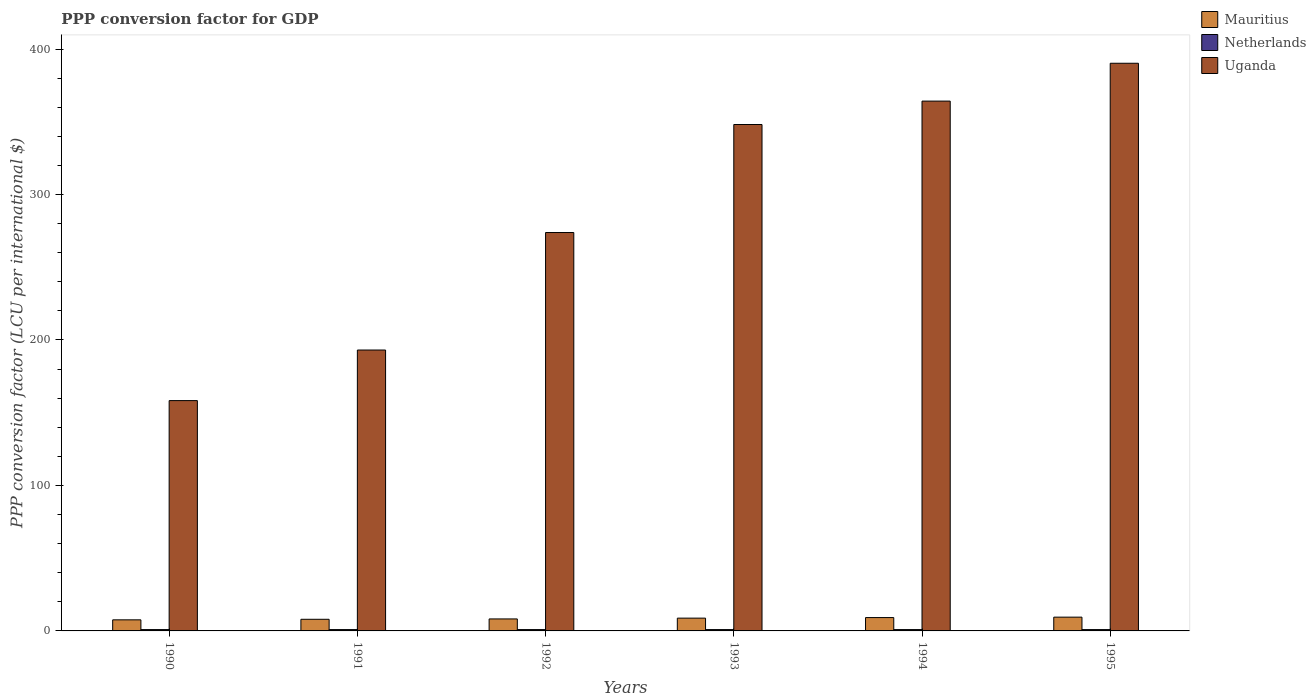How many different coloured bars are there?
Offer a very short reply. 3. Are the number of bars per tick equal to the number of legend labels?
Offer a terse response. Yes. Are the number of bars on each tick of the X-axis equal?
Keep it short and to the point. Yes. How many bars are there on the 2nd tick from the right?
Keep it short and to the point. 3. In how many cases, is the number of bars for a given year not equal to the number of legend labels?
Make the answer very short. 0. What is the PPP conversion factor for GDP in Netherlands in 1993?
Make the answer very short. 0.92. Across all years, what is the maximum PPP conversion factor for GDP in Mauritius?
Keep it short and to the point. 9.47. Across all years, what is the minimum PPP conversion factor for GDP in Netherlands?
Provide a succinct answer. 0.92. In which year was the PPP conversion factor for GDP in Mauritius minimum?
Your answer should be compact. 1990. What is the total PPP conversion factor for GDP in Uganda in the graph?
Your answer should be very brief. 1727.85. What is the difference between the PPP conversion factor for GDP in Mauritius in 1991 and that in 1993?
Your response must be concise. -0.79. What is the difference between the PPP conversion factor for GDP in Netherlands in 1992 and the PPP conversion factor for GDP in Uganda in 1991?
Ensure brevity in your answer.  -192.17. What is the average PPP conversion factor for GDP in Uganda per year?
Make the answer very short. 287.98. In the year 1993, what is the difference between the PPP conversion factor for GDP in Netherlands and PPP conversion factor for GDP in Uganda?
Keep it short and to the point. -347.21. What is the ratio of the PPP conversion factor for GDP in Netherlands in 1991 to that in 1993?
Give a very brief answer. 1.01. Is the difference between the PPP conversion factor for GDP in Netherlands in 1990 and 1991 greater than the difference between the PPP conversion factor for GDP in Uganda in 1990 and 1991?
Offer a terse response. Yes. What is the difference between the highest and the second highest PPP conversion factor for GDP in Netherlands?
Make the answer very short. 5.700000000008476e-5. What is the difference between the highest and the lowest PPP conversion factor for GDP in Mauritius?
Offer a terse response. 1.86. In how many years, is the PPP conversion factor for GDP in Netherlands greater than the average PPP conversion factor for GDP in Netherlands taken over all years?
Your answer should be compact. 3. What does the 1st bar from the left in 1995 represents?
Your response must be concise. Mauritius. What does the 2nd bar from the right in 1992 represents?
Your answer should be very brief. Netherlands. Is it the case that in every year, the sum of the PPP conversion factor for GDP in Netherlands and PPP conversion factor for GDP in Uganda is greater than the PPP conversion factor for GDP in Mauritius?
Offer a terse response. Yes. Are all the bars in the graph horizontal?
Provide a succinct answer. No. What is the difference between two consecutive major ticks on the Y-axis?
Provide a short and direct response. 100. Are the values on the major ticks of Y-axis written in scientific E-notation?
Offer a terse response. No. Where does the legend appear in the graph?
Make the answer very short. Top right. What is the title of the graph?
Offer a very short reply. PPP conversion factor for GDP. What is the label or title of the Y-axis?
Make the answer very short. PPP conversion factor (LCU per international $). What is the PPP conversion factor (LCU per international $) of Mauritius in 1990?
Ensure brevity in your answer.  7.62. What is the PPP conversion factor (LCU per international $) in Netherlands in 1990?
Give a very brief answer. 0.92. What is the PPP conversion factor (LCU per international $) of Uganda in 1990?
Provide a short and direct response. 158.32. What is the PPP conversion factor (LCU per international $) of Mauritius in 1991?
Keep it short and to the point. 8. What is the PPP conversion factor (LCU per international $) in Netherlands in 1991?
Offer a terse response. 0.92. What is the PPP conversion factor (LCU per international $) of Uganda in 1991?
Your response must be concise. 193.09. What is the PPP conversion factor (LCU per international $) of Mauritius in 1992?
Offer a terse response. 8.24. What is the PPP conversion factor (LCU per international $) in Netherlands in 1992?
Your answer should be very brief. 0.92. What is the PPP conversion factor (LCU per international $) of Uganda in 1992?
Offer a very short reply. 273.87. What is the PPP conversion factor (LCU per international $) in Mauritius in 1993?
Offer a terse response. 8.79. What is the PPP conversion factor (LCU per international $) in Netherlands in 1993?
Provide a succinct answer. 0.92. What is the PPP conversion factor (LCU per international $) in Uganda in 1993?
Provide a short and direct response. 348.12. What is the PPP conversion factor (LCU per international $) of Mauritius in 1994?
Make the answer very short. 9.17. What is the PPP conversion factor (LCU per international $) of Netherlands in 1994?
Ensure brevity in your answer.  0.92. What is the PPP conversion factor (LCU per international $) in Uganda in 1994?
Provide a succinct answer. 364.21. What is the PPP conversion factor (LCU per international $) of Mauritius in 1995?
Provide a short and direct response. 9.47. What is the PPP conversion factor (LCU per international $) of Netherlands in 1995?
Provide a succinct answer. 0.92. What is the PPP conversion factor (LCU per international $) in Uganda in 1995?
Offer a very short reply. 390.23. Across all years, what is the maximum PPP conversion factor (LCU per international $) of Mauritius?
Provide a succinct answer. 9.47. Across all years, what is the maximum PPP conversion factor (LCU per international $) in Netherlands?
Provide a short and direct response. 0.92. Across all years, what is the maximum PPP conversion factor (LCU per international $) of Uganda?
Keep it short and to the point. 390.23. Across all years, what is the minimum PPP conversion factor (LCU per international $) in Mauritius?
Your response must be concise. 7.62. Across all years, what is the minimum PPP conversion factor (LCU per international $) of Netherlands?
Keep it short and to the point. 0.92. Across all years, what is the minimum PPP conversion factor (LCU per international $) in Uganda?
Provide a short and direct response. 158.32. What is the total PPP conversion factor (LCU per international $) in Mauritius in the graph?
Provide a short and direct response. 51.3. What is the total PPP conversion factor (LCU per international $) in Netherlands in the graph?
Your answer should be compact. 5.51. What is the total PPP conversion factor (LCU per international $) of Uganda in the graph?
Give a very brief answer. 1727.85. What is the difference between the PPP conversion factor (LCU per international $) in Mauritius in 1990 and that in 1991?
Make the answer very short. -0.39. What is the difference between the PPP conversion factor (LCU per international $) in Netherlands in 1990 and that in 1991?
Your answer should be very brief. 0. What is the difference between the PPP conversion factor (LCU per international $) in Uganda in 1990 and that in 1991?
Make the answer very short. -34.77. What is the difference between the PPP conversion factor (LCU per international $) in Mauritius in 1990 and that in 1992?
Keep it short and to the point. -0.63. What is the difference between the PPP conversion factor (LCU per international $) in Netherlands in 1990 and that in 1992?
Ensure brevity in your answer.  -0. What is the difference between the PPP conversion factor (LCU per international $) of Uganda in 1990 and that in 1992?
Give a very brief answer. -115.55. What is the difference between the PPP conversion factor (LCU per international $) in Mauritius in 1990 and that in 1993?
Ensure brevity in your answer.  -1.18. What is the difference between the PPP conversion factor (LCU per international $) in Netherlands in 1990 and that in 1993?
Make the answer very short. 0.01. What is the difference between the PPP conversion factor (LCU per international $) of Uganda in 1990 and that in 1993?
Ensure brevity in your answer.  -189.8. What is the difference between the PPP conversion factor (LCU per international $) in Mauritius in 1990 and that in 1994?
Keep it short and to the point. -1.56. What is the difference between the PPP conversion factor (LCU per international $) in Netherlands in 1990 and that in 1994?
Your answer should be very brief. 0.01. What is the difference between the PPP conversion factor (LCU per international $) of Uganda in 1990 and that in 1994?
Provide a short and direct response. -205.89. What is the difference between the PPP conversion factor (LCU per international $) of Mauritius in 1990 and that in 1995?
Offer a terse response. -1.86. What is the difference between the PPP conversion factor (LCU per international $) in Netherlands in 1990 and that in 1995?
Your answer should be compact. 0.01. What is the difference between the PPP conversion factor (LCU per international $) of Uganda in 1990 and that in 1995?
Make the answer very short. -231.9. What is the difference between the PPP conversion factor (LCU per international $) in Mauritius in 1991 and that in 1992?
Your response must be concise. -0.24. What is the difference between the PPP conversion factor (LCU per international $) of Netherlands in 1991 and that in 1992?
Offer a terse response. -0. What is the difference between the PPP conversion factor (LCU per international $) in Uganda in 1991 and that in 1992?
Provide a short and direct response. -80.78. What is the difference between the PPP conversion factor (LCU per international $) in Mauritius in 1991 and that in 1993?
Your response must be concise. -0.79. What is the difference between the PPP conversion factor (LCU per international $) of Netherlands in 1991 and that in 1993?
Give a very brief answer. 0.01. What is the difference between the PPP conversion factor (LCU per international $) in Uganda in 1991 and that in 1993?
Offer a terse response. -155.03. What is the difference between the PPP conversion factor (LCU per international $) of Mauritius in 1991 and that in 1994?
Ensure brevity in your answer.  -1.17. What is the difference between the PPP conversion factor (LCU per international $) of Netherlands in 1991 and that in 1994?
Your answer should be very brief. 0.01. What is the difference between the PPP conversion factor (LCU per international $) in Uganda in 1991 and that in 1994?
Your answer should be compact. -171.12. What is the difference between the PPP conversion factor (LCU per international $) in Mauritius in 1991 and that in 1995?
Your answer should be very brief. -1.47. What is the difference between the PPP conversion factor (LCU per international $) of Netherlands in 1991 and that in 1995?
Provide a short and direct response. 0.01. What is the difference between the PPP conversion factor (LCU per international $) of Uganda in 1991 and that in 1995?
Give a very brief answer. -197.13. What is the difference between the PPP conversion factor (LCU per international $) in Mauritius in 1992 and that in 1993?
Offer a terse response. -0.55. What is the difference between the PPP conversion factor (LCU per international $) in Netherlands in 1992 and that in 1993?
Make the answer very short. 0.01. What is the difference between the PPP conversion factor (LCU per international $) of Uganda in 1992 and that in 1993?
Your response must be concise. -74.25. What is the difference between the PPP conversion factor (LCU per international $) in Mauritius in 1992 and that in 1994?
Make the answer very short. -0.93. What is the difference between the PPP conversion factor (LCU per international $) of Netherlands in 1992 and that in 1994?
Your answer should be compact. 0.01. What is the difference between the PPP conversion factor (LCU per international $) of Uganda in 1992 and that in 1994?
Offer a terse response. -90.34. What is the difference between the PPP conversion factor (LCU per international $) in Mauritius in 1992 and that in 1995?
Offer a terse response. -1.23. What is the difference between the PPP conversion factor (LCU per international $) in Netherlands in 1992 and that in 1995?
Offer a terse response. 0.01. What is the difference between the PPP conversion factor (LCU per international $) of Uganda in 1992 and that in 1995?
Your answer should be compact. -116.36. What is the difference between the PPP conversion factor (LCU per international $) in Mauritius in 1993 and that in 1994?
Your answer should be compact. -0.38. What is the difference between the PPP conversion factor (LCU per international $) in Netherlands in 1993 and that in 1994?
Ensure brevity in your answer.  0. What is the difference between the PPP conversion factor (LCU per international $) in Uganda in 1993 and that in 1994?
Give a very brief answer. -16.09. What is the difference between the PPP conversion factor (LCU per international $) in Mauritius in 1993 and that in 1995?
Your answer should be compact. -0.68. What is the difference between the PPP conversion factor (LCU per international $) in Netherlands in 1993 and that in 1995?
Provide a short and direct response. 0. What is the difference between the PPP conversion factor (LCU per international $) of Uganda in 1993 and that in 1995?
Give a very brief answer. -42.1. What is the difference between the PPP conversion factor (LCU per international $) of Mauritius in 1994 and that in 1995?
Provide a short and direct response. -0.3. What is the difference between the PPP conversion factor (LCU per international $) in Uganda in 1994 and that in 1995?
Offer a very short reply. -26.01. What is the difference between the PPP conversion factor (LCU per international $) in Mauritius in 1990 and the PPP conversion factor (LCU per international $) in Netherlands in 1991?
Keep it short and to the point. 6.69. What is the difference between the PPP conversion factor (LCU per international $) in Mauritius in 1990 and the PPP conversion factor (LCU per international $) in Uganda in 1991?
Keep it short and to the point. -185.48. What is the difference between the PPP conversion factor (LCU per international $) in Netherlands in 1990 and the PPP conversion factor (LCU per international $) in Uganda in 1991?
Provide a succinct answer. -192.17. What is the difference between the PPP conversion factor (LCU per international $) in Mauritius in 1990 and the PPP conversion factor (LCU per international $) in Netherlands in 1992?
Give a very brief answer. 6.69. What is the difference between the PPP conversion factor (LCU per international $) in Mauritius in 1990 and the PPP conversion factor (LCU per international $) in Uganda in 1992?
Provide a short and direct response. -266.26. What is the difference between the PPP conversion factor (LCU per international $) in Netherlands in 1990 and the PPP conversion factor (LCU per international $) in Uganda in 1992?
Give a very brief answer. -272.95. What is the difference between the PPP conversion factor (LCU per international $) of Mauritius in 1990 and the PPP conversion factor (LCU per international $) of Netherlands in 1993?
Your answer should be very brief. 6.7. What is the difference between the PPP conversion factor (LCU per international $) in Mauritius in 1990 and the PPP conversion factor (LCU per international $) in Uganda in 1993?
Your response must be concise. -340.51. What is the difference between the PPP conversion factor (LCU per international $) of Netherlands in 1990 and the PPP conversion factor (LCU per international $) of Uganda in 1993?
Make the answer very short. -347.2. What is the difference between the PPP conversion factor (LCU per international $) in Mauritius in 1990 and the PPP conversion factor (LCU per international $) in Netherlands in 1994?
Your response must be concise. 6.7. What is the difference between the PPP conversion factor (LCU per international $) in Mauritius in 1990 and the PPP conversion factor (LCU per international $) in Uganda in 1994?
Your answer should be very brief. -356.6. What is the difference between the PPP conversion factor (LCU per international $) of Netherlands in 1990 and the PPP conversion factor (LCU per international $) of Uganda in 1994?
Give a very brief answer. -363.29. What is the difference between the PPP conversion factor (LCU per international $) of Mauritius in 1990 and the PPP conversion factor (LCU per international $) of Netherlands in 1995?
Offer a very short reply. 6.7. What is the difference between the PPP conversion factor (LCU per international $) of Mauritius in 1990 and the PPP conversion factor (LCU per international $) of Uganda in 1995?
Your answer should be very brief. -382.61. What is the difference between the PPP conversion factor (LCU per international $) in Netherlands in 1990 and the PPP conversion factor (LCU per international $) in Uganda in 1995?
Your response must be concise. -389.3. What is the difference between the PPP conversion factor (LCU per international $) of Mauritius in 1991 and the PPP conversion factor (LCU per international $) of Netherlands in 1992?
Keep it short and to the point. 7.08. What is the difference between the PPP conversion factor (LCU per international $) in Mauritius in 1991 and the PPP conversion factor (LCU per international $) in Uganda in 1992?
Your answer should be compact. -265.87. What is the difference between the PPP conversion factor (LCU per international $) of Netherlands in 1991 and the PPP conversion factor (LCU per international $) of Uganda in 1992?
Make the answer very short. -272.95. What is the difference between the PPP conversion factor (LCU per international $) of Mauritius in 1991 and the PPP conversion factor (LCU per international $) of Netherlands in 1993?
Ensure brevity in your answer.  7.09. What is the difference between the PPP conversion factor (LCU per international $) of Mauritius in 1991 and the PPP conversion factor (LCU per international $) of Uganda in 1993?
Your answer should be very brief. -340.12. What is the difference between the PPP conversion factor (LCU per international $) in Netherlands in 1991 and the PPP conversion factor (LCU per international $) in Uganda in 1993?
Give a very brief answer. -347.2. What is the difference between the PPP conversion factor (LCU per international $) of Mauritius in 1991 and the PPP conversion factor (LCU per international $) of Netherlands in 1994?
Offer a terse response. 7.09. What is the difference between the PPP conversion factor (LCU per international $) in Mauritius in 1991 and the PPP conversion factor (LCU per international $) in Uganda in 1994?
Offer a very short reply. -356.21. What is the difference between the PPP conversion factor (LCU per international $) of Netherlands in 1991 and the PPP conversion factor (LCU per international $) of Uganda in 1994?
Keep it short and to the point. -363.29. What is the difference between the PPP conversion factor (LCU per international $) of Mauritius in 1991 and the PPP conversion factor (LCU per international $) of Netherlands in 1995?
Make the answer very short. 7.09. What is the difference between the PPP conversion factor (LCU per international $) of Mauritius in 1991 and the PPP conversion factor (LCU per international $) of Uganda in 1995?
Provide a short and direct response. -382.22. What is the difference between the PPP conversion factor (LCU per international $) of Netherlands in 1991 and the PPP conversion factor (LCU per international $) of Uganda in 1995?
Your answer should be compact. -389.31. What is the difference between the PPP conversion factor (LCU per international $) in Mauritius in 1992 and the PPP conversion factor (LCU per international $) in Netherlands in 1993?
Ensure brevity in your answer.  7.33. What is the difference between the PPP conversion factor (LCU per international $) of Mauritius in 1992 and the PPP conversion factor (LCU per international $) of Uganda in 1993?
Offer a terse response. -339.88. What is the difference between the PPP conversion factor (LCU per international $) in Netherlands in 1992 and the PPP conversion factor (LCU per international $) in Uganda in 1993?
Provide a succinct answer. -347.2. What is the difference between the PPP conversion factor (LCU per international $) in Mauritius in 1992 and the PPP conversion factor (LCU per international $) in Netherlands in 1994?
Offer a very short reply. 7.33. What is the difference between the PPP conversion factor (LCU per international $) of Mauritius in 1992 and the PPP conversion factor (LCU per international $) of Uganda in 1994?
Your response must be concise. -355.97. What is the difference between the PPP conversion factor (LCU per international $) in Netherlands in 1992 and the PPP conversion factor (LCU per international $) in Uganda in 1994?
Your response must be concise. -363.29. What is the difference between the PPP conversion factor (LCU per international $) in Mauritius in 1992 and the PPP conversion factor (LCU per international $) in Netherlands in 1995?
Keep it short and to the point. 7.33. What is the difference between the PPP conversion factor (LCU per international $) of Mauritius in 1992 and the PPP conversion factor (LCU per international $) of Uganda in 1995?
Offer a very short reply. -381.98. What is the difference between the PPP conversion factor (LCU per international $) of Netherlands in 1992 and the PPP conversion factor (LCU per international $) of Uganda in 1995?
Provide a succinct answer. -389.3. What is the difference between the PPP conversion factor (LCU per international $) of Mauritius in 1993 and the PPP conversion factor (LCU per international $) of Netherlands in 1994?
Your answer should be very brief. 7.88. What is the difference between the PPP conversion factor (LCU per international $) of Mauritius in 1993 and the PPP conversion factor (LCU per international $) of Uganda in 1994?
Make the answer very short. -355.42. What is the difference between the PPP conversion factor (LCU per international $) in Netherlands in 1993 and the PPP conversion factor (LCU per international $) in Uganda in 1994?
Keep it short and to the point. -363.3. What is the difference between the PPP conversion factor (LCU per international $) of Mauritius in 1993 and the PPP conversion factor (LCU per international $) of Netherlands in 1995?
Give a very brief answer. 7.88. What is the difference between the PPP conversion factor (LCU per international $) of Mauritius in 1993 and the PPP conversion factor (LCU per international $) of Uganda in 1995?
Give a very brief answer. -381.43. What is the difference between the PPP conversion factor (LCU per international $) in Netherlands in 1993 and the PPP conversion factor (LCU per international $) in Uganda in 1995?
Offer a very short reply. -389.31. What is the difference between the PPP conversion factor (LCU per international $) of Mauritius in 1994 and the PPP conversion factor (LCU per international $) of Netherlands in 1995?
Keep it short and to the point. 8.26. What is the difference between the PPP conversion factor (LCU per international $) of Mauritius in 1994 and the PPP conversion factor (LCU per international $) of Uganda in 1995?
Your response must be concise. -381.05. What is the difference between the PPP conversion factor (LCU per international $) of Netherlands in 1994 and the PPP conversion factor (LCU per international $) of Uganda in 1995?
Provide a succinct answer. -389.31. What is the average PPP conversion factor (LCU per international $) of Mauritius per year?
Provide a short and direct response. 8.55. What is the average PPP conversion factor (LCU per international $) in Netherlands per year?
Offer a very short reply. 0.92. What is the average PPP conversion factor (LCU per international $) in Uganda per year?
Provide a short and direct response. 287.98. In the year 1990, what is the difference between the PPP conversion factor (LCU per international $) of Mauritius and PPP conversion factor (LCU per international $) of Netherlands?
Ensure brevity in your answer.  6.69. In the year 1990, what is the difference between the PPP conversion factor (LCU per international $) of Mauritius and PPP conversion factor (LCU per international $) of Uganda?
Offer a very short reply. -150.71. In the year 1990, what is the difference between the PPP conversion factor (LCU per international $) in Netherlands and PPP conversion factor (LCU per international $) in Uganda?
Offer a very short reply. -157.4. In the year 1991, what is the difference between the PPP conversion factor (LCU per international $) of Mauritius and PPP conversion factor (LCU per international $) of Netherlands?
Ensure brevity in your answer.  7.08. In the year 1991, what is the difference between the PPP conversion factor (LCU per international $) in Mauritius and PPP conversion factor (LCU per international $) in Uganda?
Provide a succinct answer. -185.09. In the year 1991, what is the difference between the PPP conversion factor (LCU per international $) in Netherlands and PPP conversion factor (LCU per international $) in Uganda?
Your answer should be very brief. -192.17. In the year 1992, what is the difference between the PPP conversion factor (LCU per international $) in Mauritius and PPP conversion factor (LCU per international $) in Netherlands?
Keep it short and to the point. 7.32. In the year 1992, what is the difference between the PPP conversion factor (LCU per international $) of Mauritius and PPP conversion factor (LCU per international $) of Uganda?
Ensure brevity in your answer.  -265.63. In the year 1992, what is the difference between the PPP conversion factor (LCU per international $) of Netherlands and PPP conversion factor (LCU per international $) of Uganda?
Your response must be concise. -272.95. In the year 1993, what is the difference between the PPP conversion factor (LCU per international $) in Mauritius and PPP conversion factor (LCU per international $) in Netherlands?
Your response must be concise. 7.88. In the year 1993, what is the difference between the PPP conversion factor (LCU per international $) of Mauritius and PPP conversion factor (LCU per international $) of Uganda?
Make the answer very short. -339.33. In the year 1993, what is the difference between the PPP conversion factor (LCU per international $) of Netherlands and PPP conversion factor (LCU per international $) of Uganda?
Give a very brief answer. -347.21. In the year 1994, what is the difference between the PPP conversion factor (LCU per international $) of Mauritius and PPP conversion factor (LCU per international $) of Netherlands?
Ensure brevity in your answer.  8.26. In the year 1994, what is the difference between the PPP conversion factor (LCU per international $) in Mauritius and PPP conversion factor (LCU per international $) in Uganda?
Provide a succinct answer. -355.04. In the year 1994, what is the difference between the PPP conversion factor (LCU per international $) in Netherlands and PPP conversion factor (LCU per international $) in Uganda?
Provide a short and direct response. -363.3. In the year 1995, what is the difference between the PPP conversion factor (LCU per international $) in Mauritius and PPP conversion factor (LCU per international $) in Netherlands?
Offer a very short reply. 8.56. In the year 1995, what is the difference between the PPP conversion factor (LCU per international $) of Mauritius and PPP conversion factor (LCU per international $) of Uganda?
Offer a very short reply. -380.75. In the year 1995, what is the difference between the PPP conversion factor (LCU per international $) in Netherlands and PPP conversion factor (LCU per international $) in Uganda?
Provide a succinct answer. -389.31. What is the ratio of the PPP conversion factor (LCU per international $) in Mauritius in 1990 to that in 1991?
Keep it short and to the point. 0.95. What is the ratio of the PPP conversion factor (LCU per international $) of Netherlands in 1990 to that in 1991?
Your response must be concise. 1. What is the ratio of the PPP conversion factor (LCU per international $) in Uganda in 1990 to that in 1991?
Your answer should be very brief. 0.82. What is the ratio of the PPP conversion factor (LCU per international $) in Mauritius in 1990 to that in 1992?
Make the answer very short. 0.92. What is the ratio of the PPP conversion factor (LCU per international $) of Uganda in 1990 to that in 1992?
Your answer should be compact. 0.58. What is the ratio of the PPP conversion factor (LCU per international $) of Mauritius in 1990 to that in 1993?
Give a very brief answer. 0.87. What is the ratio of the PPP conversion factor (LCU per international $) of Netherlands in 1990 to that in 1993?
Your answer should be compact. 1.01. What is the ratio of the PPP conversion factor (LCU per international $) of Uganda in 1990 to that in 1993?
Ensure brevity in your answer.  0.45. What is the ratio of the PPP conversion factor (LCU per international $) in Mauritius in 1990 to that in 1994?
Make the answer very short. 0.83. What is the ratio of the PPP conversion factor (LCU per international $) in Netherlands in 1990 to that in 1994?
Provide a succinct answer. 1.01. What is the ratio of the PPP conversion factor (LCU per international $) in Uganda in 1990 to that in 1994?
Your answer should be very brief. 0.43. What is the ratio of the PPP conversion factor (LCU per international $) of Mauritius in 1990 to that in 1995?
Offer a very short reply. 0.8. What is the ratio of the PPP conversion factor (LCU per international $) of Netherlands in 1990 to that in 1995?
Offer a terse response. 1.01. What is the ratio of the PPP conversion factor (LCU per international $) in Uganda in 1990 to that in 1995?
Offer a very short reply. 0.41. What is the ratio of the PPP conversion factor (LCU per international $) in Mauritius in 1991 to that in 1992?
Give a very brief answer. 0.97. What is the ratio of the PPP conversion factor (LCU per international $) of Netherlands in 1991 to that in 1992?
Give a very brief answer. 1. What is the ratio of the PPP conversion factor (LCU per international $) of Uganda in 1991 to that in 1992?
Your response must be concise. 0.7. What is the ratio of the PPP conversion factor (LCU per international $) of Mauritius in 1991 to that in 1993?
Your answer should be very brief. 0.91. What is the ratio of the PPP conversion factor (LCU per international $) in Netherlands in 1991 to that in 1993?
Offer a terse response. 1.01. What is the ratio of the PPP conversion factor (LCU per international $) in Uganda in 1991 to that in 1993?
Keep it short and to the point. 0.55. What is the ratio of the PPP conversion factor (LCU per international $) in Mauritius in 1991 to that in 1994?
Provide a succinct answer. 0.87. What is the ratio of the PPP conversion factor (LCU per international $) in Uganda in 1991 to that in 1994?
Keep it short and to the point. 0.53. What is the ratio of the PPP conversion factor (LCU per international $) of Mauritius in 1991 to that in 1995?
Provide a short and direct response. 0.84. What is the ratio of the PPP conversion factor (LCU per international $) in Netherlands in 1991 to that in 1995?
Provide a short and direct response. 1.01. What is the ratio of the PPP conversion factor (LCU per international $) in Uganda in 1991 to that in 1995?
Keep it short and to the point. 0.49. What is the ratio of the PPP conversion factor (LCU per international $) in Mauritius in 1992 to that in 1993?
Your answer should be very brief. 0.94. What is the ratio of the PPP conversion factor (LCU per international $) in Netherlands in 1992 to that in 1993?
Make the answer very short. 1.01. What is the ratio of the PPP conversion factor (LCU per international $) of Uganda in 1992 to that in 1993?
Provide a short and direct response. 0.79. What is the ratio of the PPP conversion factor (LCU per international $) of Mauritius in 1992 to that in 1994?
Your answer should be compact. 0.9. What is the ratio of the PPP conversion factor (LCU per international $) in Netherlands in 1992 to that in 1994?
Your response must be concise. 1.01. What is the ratio of the PPP conversion factor (LCU per international $) in Uganda in 1992 to that in 1994?
Your answer should be very brief. 0.75. What is the ratio of the PPP conversion factor (LCU per international $) of Mauritius in 1992 to that in 1995?
Ensure brevity in your answer.  0.87. What is the ratio of the PPP conversion factor (LCU per international $) of Netherlands in 1992 to that in 1995?
Your response must be concise. 1.01. What is the ratio of the PPP conversion factor (LCU per international $) of Uganda in 1992 to that in 1995?
Keep it short and to the point. 0.7. What is the ratio of the PPP conversion factor (LCU per international $) in Mauritius in 1993 to that in 1994?
Keep it short and to the point. 0.96. What is the ratio of the PPP conversion factor (LCU per international $) in Netherlands in 1993 to that in 1994?
Ensure brevity in your answer.  1. What is the ratio of the PPP conversion factor (LCU per international $) of Uganda in 1993 to that in 1994?
Make the answer very short. 0.96. What is the ratio of the PPP conversion factor (LCU per international $) in Mauritius in 1993 to that in 1995?
Ensure brevity in your answer.  0.93. What is the ratio of the PPP conversion factor (LCU per international $) of Netherlands in 1993 to that in 1995?
Give a very brief answer. 1. What is the ratio of the PPP conversion factor (LCU per international $) of Uganda in 1993 to that in 1995?
Offer a very short reply. 0.89. What is the ratio of the PPP conversion factor (LCU per international $) in Mauritius in 1994 to that in 1995?
Provide a short and direct response. 0.97. What is the ratio of the PPP conversion factor (LCU per international $) of Netherlands in 1994 to that in 1995?
Provide a short and direct response. 1. What is the difference between the highest and the second highest PPP conversion factor (LCU per international $) in Mauritius?
Your answer should be compact. 0.3. What is the difference between the highest and the second highest PPP conversion factor (LCU per international $) in Uganda?
Offer a very short reply. 26.01. What is the difference between the highest and the lowest PPP conversion factor (LCU per international $) of Mauritius?
Provide a succinct answer. 1.86. What is the difference between the highest and the lowest PPP conversion factor (LCU per international $) of Netherlands?
Provide a short and direct response. 0.01. What is the difference between the highest and the lowest PPP conversion factor (LCU per international $) in Uganda?
Your response must be concise. 231.9. 